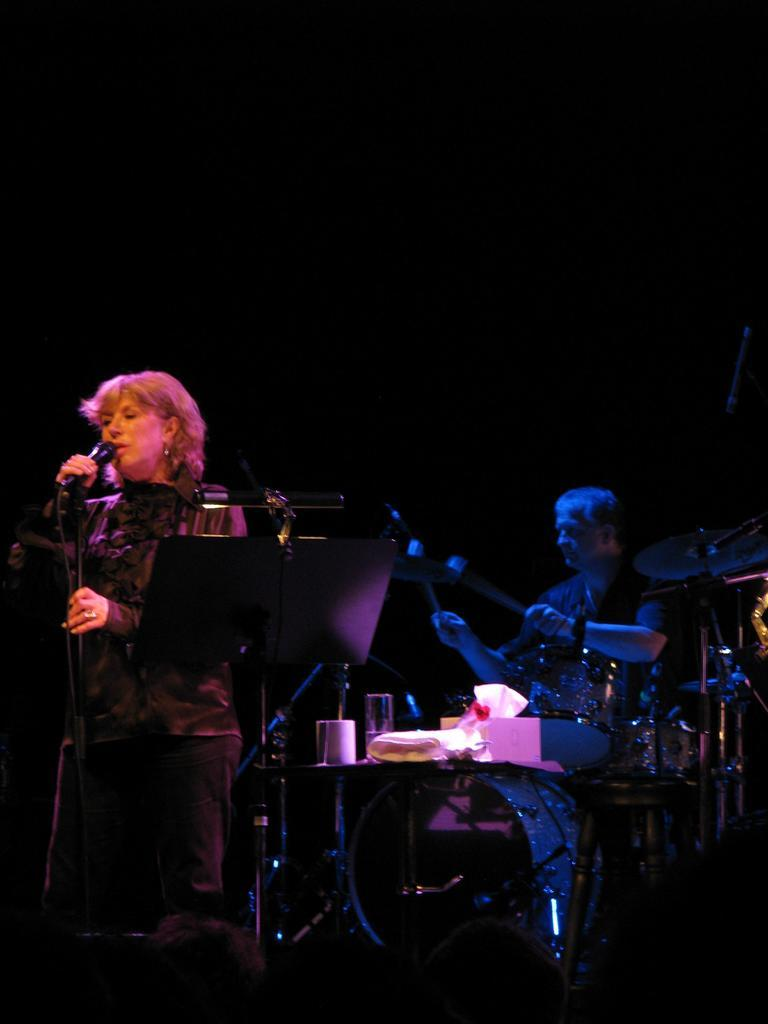What is the man in the image doing? The man is beating drums. Who else is present in the image? There is a woman in the image. What is the woman holding? The woman is holding a microphone. How is the woman positioned in the image? The woman is standing. What can be observed about the background of the image? The background of the image has a dark view. What type of cord is the woman using to hold the microphone in the image? There is no visible cord in the image; the woman is holding the microphone without any visible means of support. 